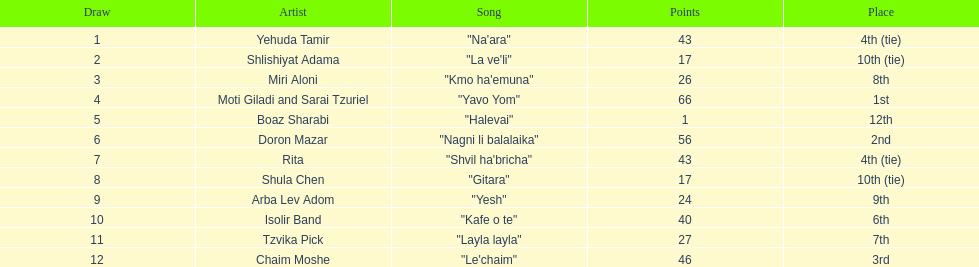What track accumulated the most points? "Yavo Yom". 